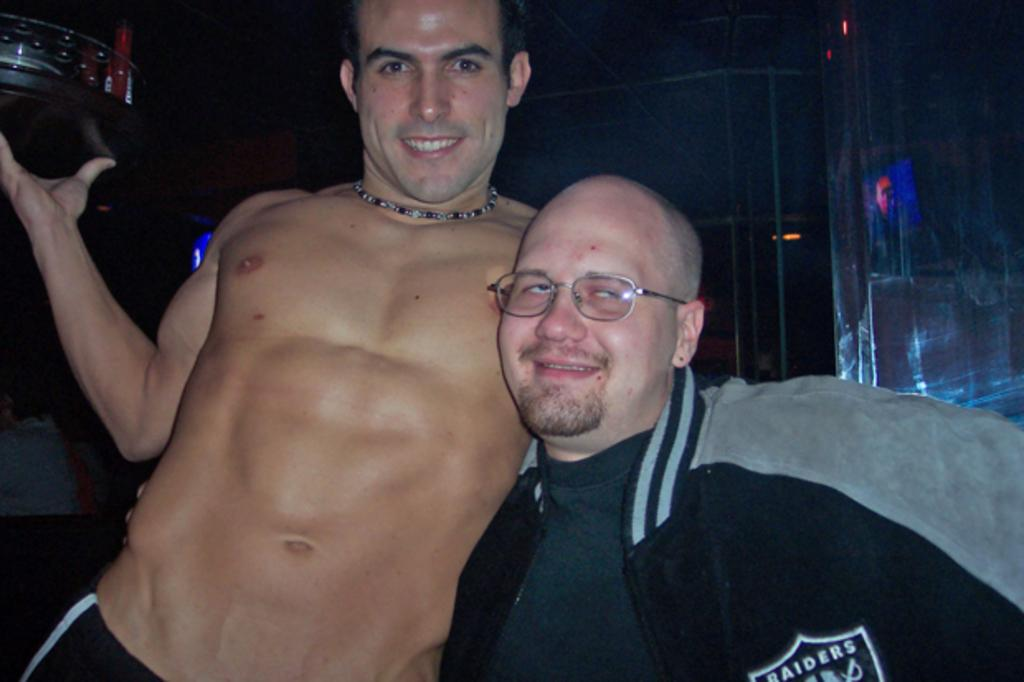How many people are in the image? There are two men in the image. What expressions do the men have? Both men are smiling. Can you describe the clothing of the man on the right side? The man on the right side is wearing a jacket. What can be seen in the background of the image? There are objects visible in the background of the image. How would you describe the lighting in the image? The background appears to be dark. What book is the man on the left side reading in the image? There is no book present in the image, and the man on the left side is not reading. Can you see a bridge in the background of the image? There is no bridge visible in the background of the image. 